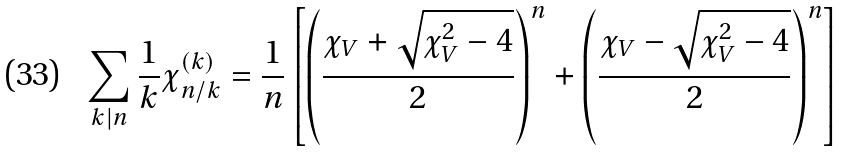Convert formula to latex. <formula><loc_0><loc_0><loc_500><loc_500>\sum _ { k | n } \frac { 1 } { k } \chi ^ { ( k ) } _ { n / k } = \frac { 1 } { n } \left [ \left ( \frac { \chi _ { V } + \sqrt { \chi _ { V } ^ { 2 } - 4 } } { 2 } \right ) ^ { n } + \left ( \frac { \chi _ { V } - \sqrt { \chi _ { V } ^ { 2 } - 4 } } { 2 } \right ) ^ { n } \right ]</formula> 